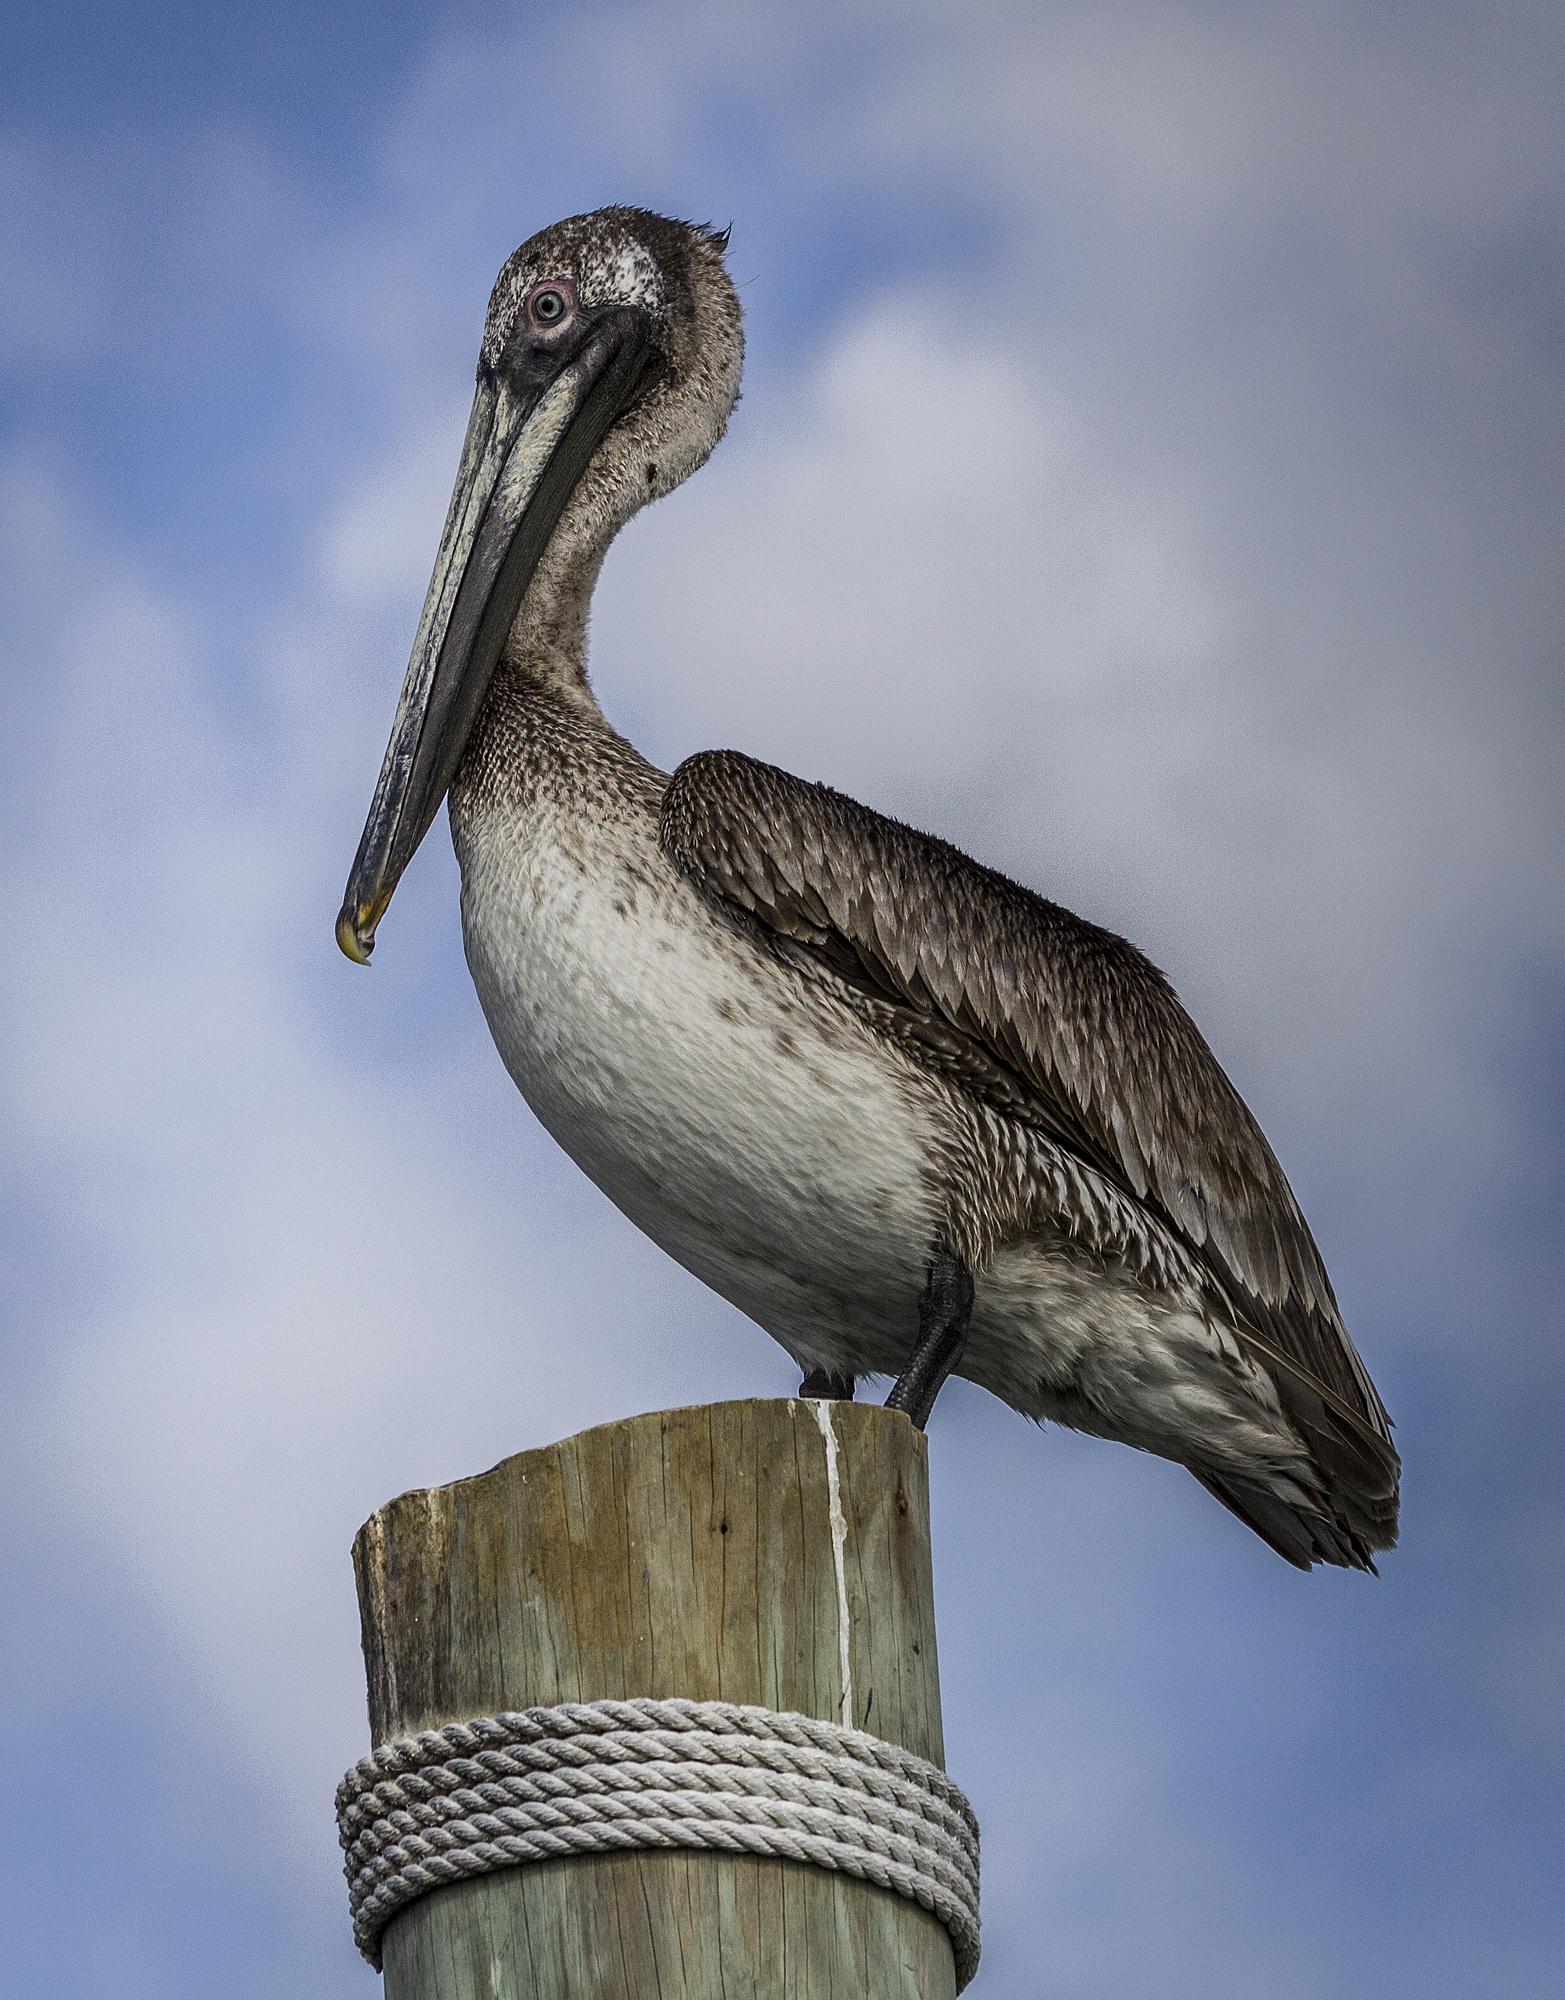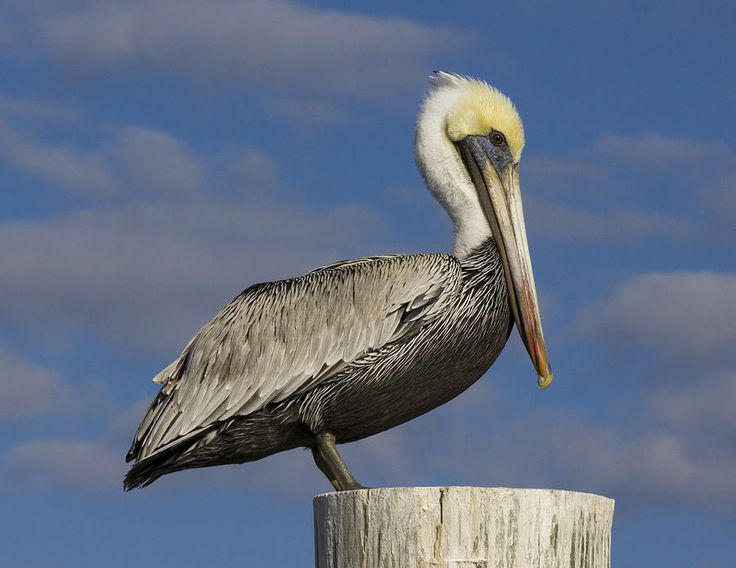The first image is the image on the left, the second image is the image on the right. Analyze the images presented: Is the assertion "In the left image, a pelican is facing right and sitting with its neck buried in its body." valid? Answer yes or no. No. The first image is the image on the left, the second image is the image on the right. Analyze the images presented: Is the assertion "Each image shows one pelican perched on a post, and at least one of the birds depicted is facing rightward." valid? Answer yes or no. Yes. 